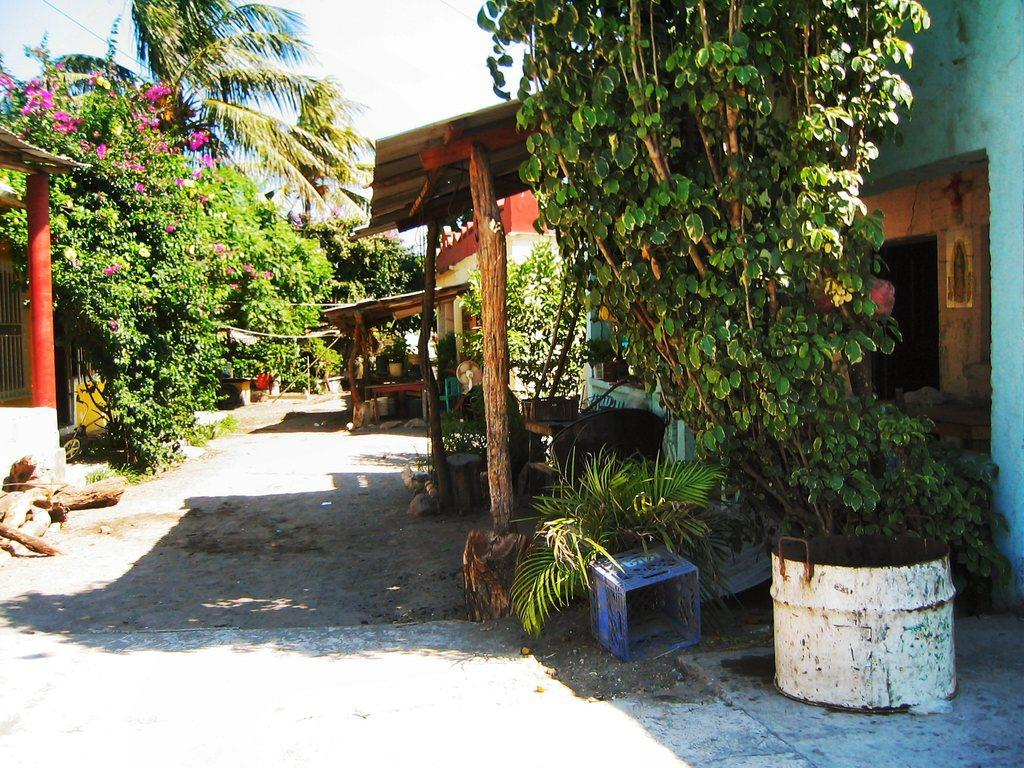What type of structures can be seen in the image? There are houses in the image. What natural elements are present in the image? There are trees in the image. What part of a tree can be seen on the ground in the image? A tree bark is present on the ground in the image. What type of container is visible in the image? There is a plastic basket in the image. How would you describe the sky in the image? The sky is cloudy in the image. Where is the lunchroom located in the image? There is no mention of a lunchroom in the image; it only features houses, trees, tree bark, a plastic basket, and a cloudy sky. 